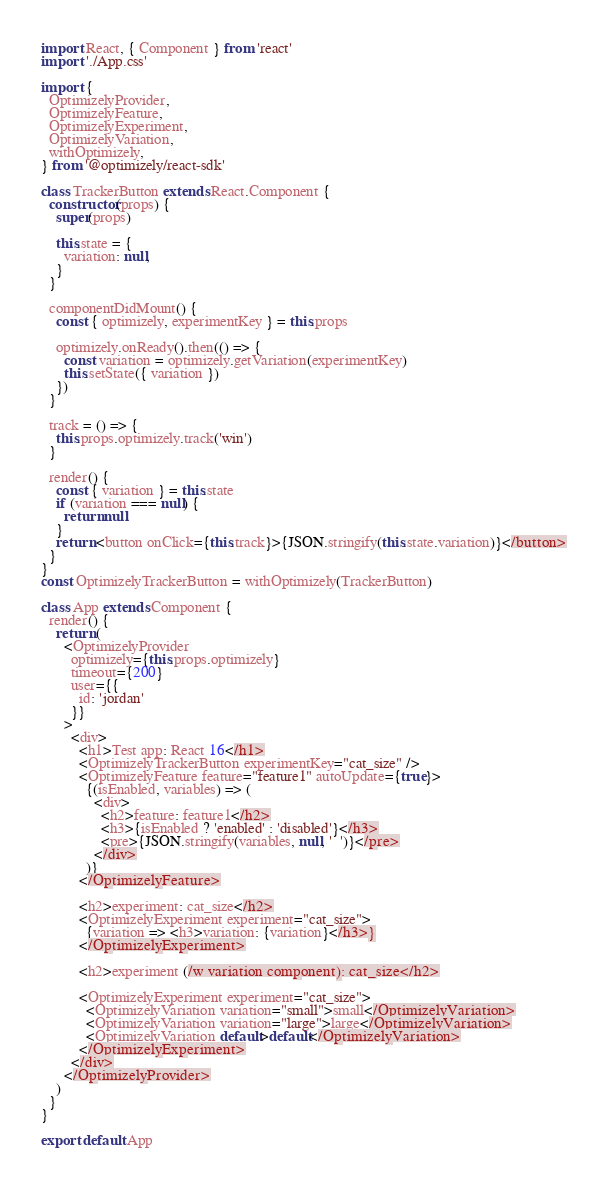<code> <loc_0><loc_0><loc_500><loc_500><_JavaScript_>import React, { Component } from 'react'
import './App.css'

import {
  OptimizelyProvider,
  OptimizelyFeature,
  OptimizelyExperiment,
  OptimizelyVariation,
  withOptimizely,
} from '@optimizely/react-sdk'

class TrackerButton extends React.Component {
  constructor(props) {
    super(props)

    this.state = {
      variation: null,
    }
  }

  componentDidMount() {
    const { optimizely, experimentKey } = this.props

    optimizely.onReady().then(() => {
      const variation = optimizely.getVariation(experimentKey)
      this.setState({ variation })
    })
  }

  track = () => {
    this.props.optimizely.track('win')
  }

  render() {
    const { variation } = this.state
    if (variation === null) {
      return null
    }
    return <button onClick={this.track}>{JSON.stringify(this.state.variation)}</button>
  }
}
const OptimizelyTrackerButton = withOptimizely(TrackerButton)

class App extends Component {
  render() {
    return (
      <OptimizelyProvider
        optimizely={this.props.optimizely}
        timeout={200}
        user={{
          id: 'jordan'
        }}
      >
        <div>
          <h1>Test app: React 16</h1>
          <OptimizelyTrackerButton experimentKey="cat_size" />
          <OptimizelyFeature feature="feature1" autoUpdate={true}>
            {(isEnabled, variables) => (
              <div>
                <h2>feature: feature1</h2>
                <h3>{isEnabled ? 'enabled' : 'disabled'}</h3>
                <pre>{JSON.stringify(variables, null, '  ')}</pre>
              </div>
            )}
          </OptimizelyFeature>

          <h2>experiment: cat_size</h2>
          <OptimizelyExperiment experiment="cat_size">
            {variation => <h3>variation: {variation}</h3>}
          </OptimizelyExperiment>

          <h2>experiment (/w variation component): cat_size</h2>

          <OptimizelyExperiment experiment="cat_size">
            <OptimizelyVariation variation="small">small</OptimizelyVariation>
            <OptimizelyVariation variation="large">large</OptimizelyVariation>
            <OptimizelyVariation default>default</OptimizelyVariation>
          </OptimizelyExperiment>
        </div>
      </OptimizelyProvider>
    )
  }
}

export default App
</code> 